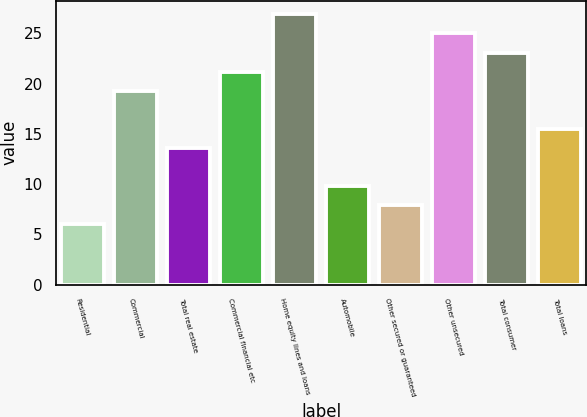Convert chart. <chart><loc_0><loc_0><loc_500><loc_500><bar_chart><fcel>Residential<fcel>Commercial<fcel>Total real estate<fcel>Commercial financial etc<fcel>Home equity lines and loans<fcel>Automobile<fcel>Other secured or guaranteed<fcel>Other unsecured<fcel>Total consumer<fcel>Total loans<nl><fcel>6<fcel>19.3<fcel>13.6<fcel>21.2<fcel>26.9<fcel>9.8<fcel>7.9<fcel>25<fcel>23.1<fcel>15.5<nl></chart> 